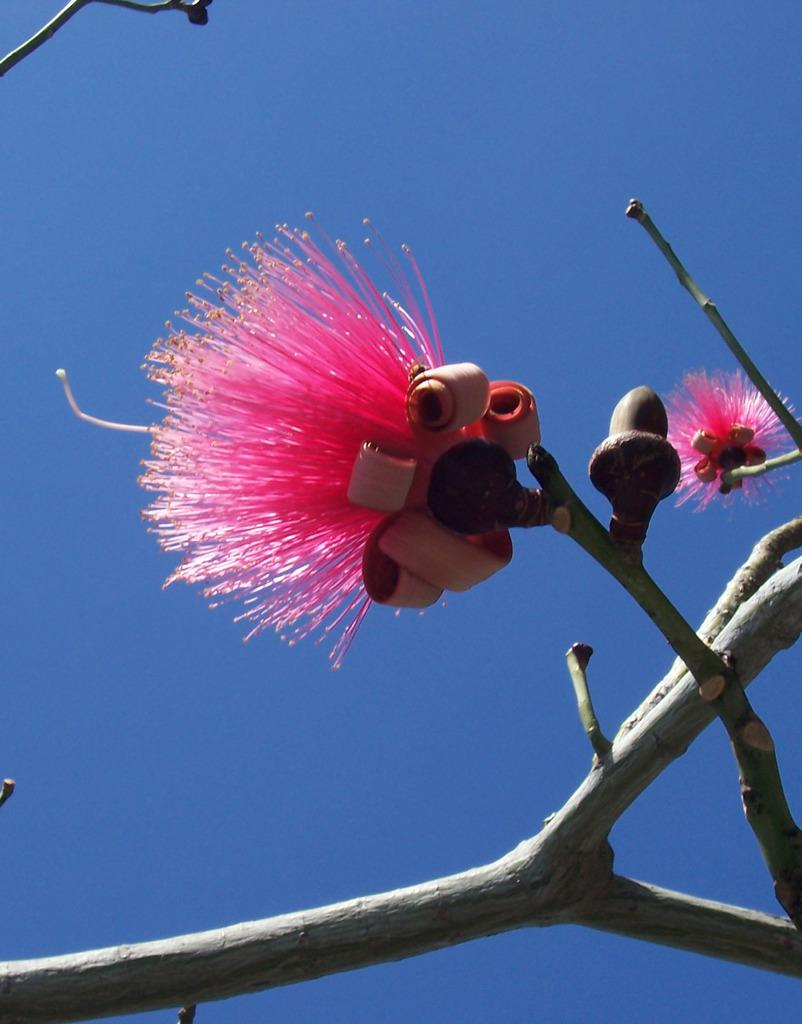What color are the flowers on the tree in the image? The flowers on the tree are pink in color. What can be seen at the top of the image? The sky is visible at the top of the image. Are there any toes visible in the image? There are no toes present in the image. What type of reading material is being used in the image? There is no reading material present in the image. 